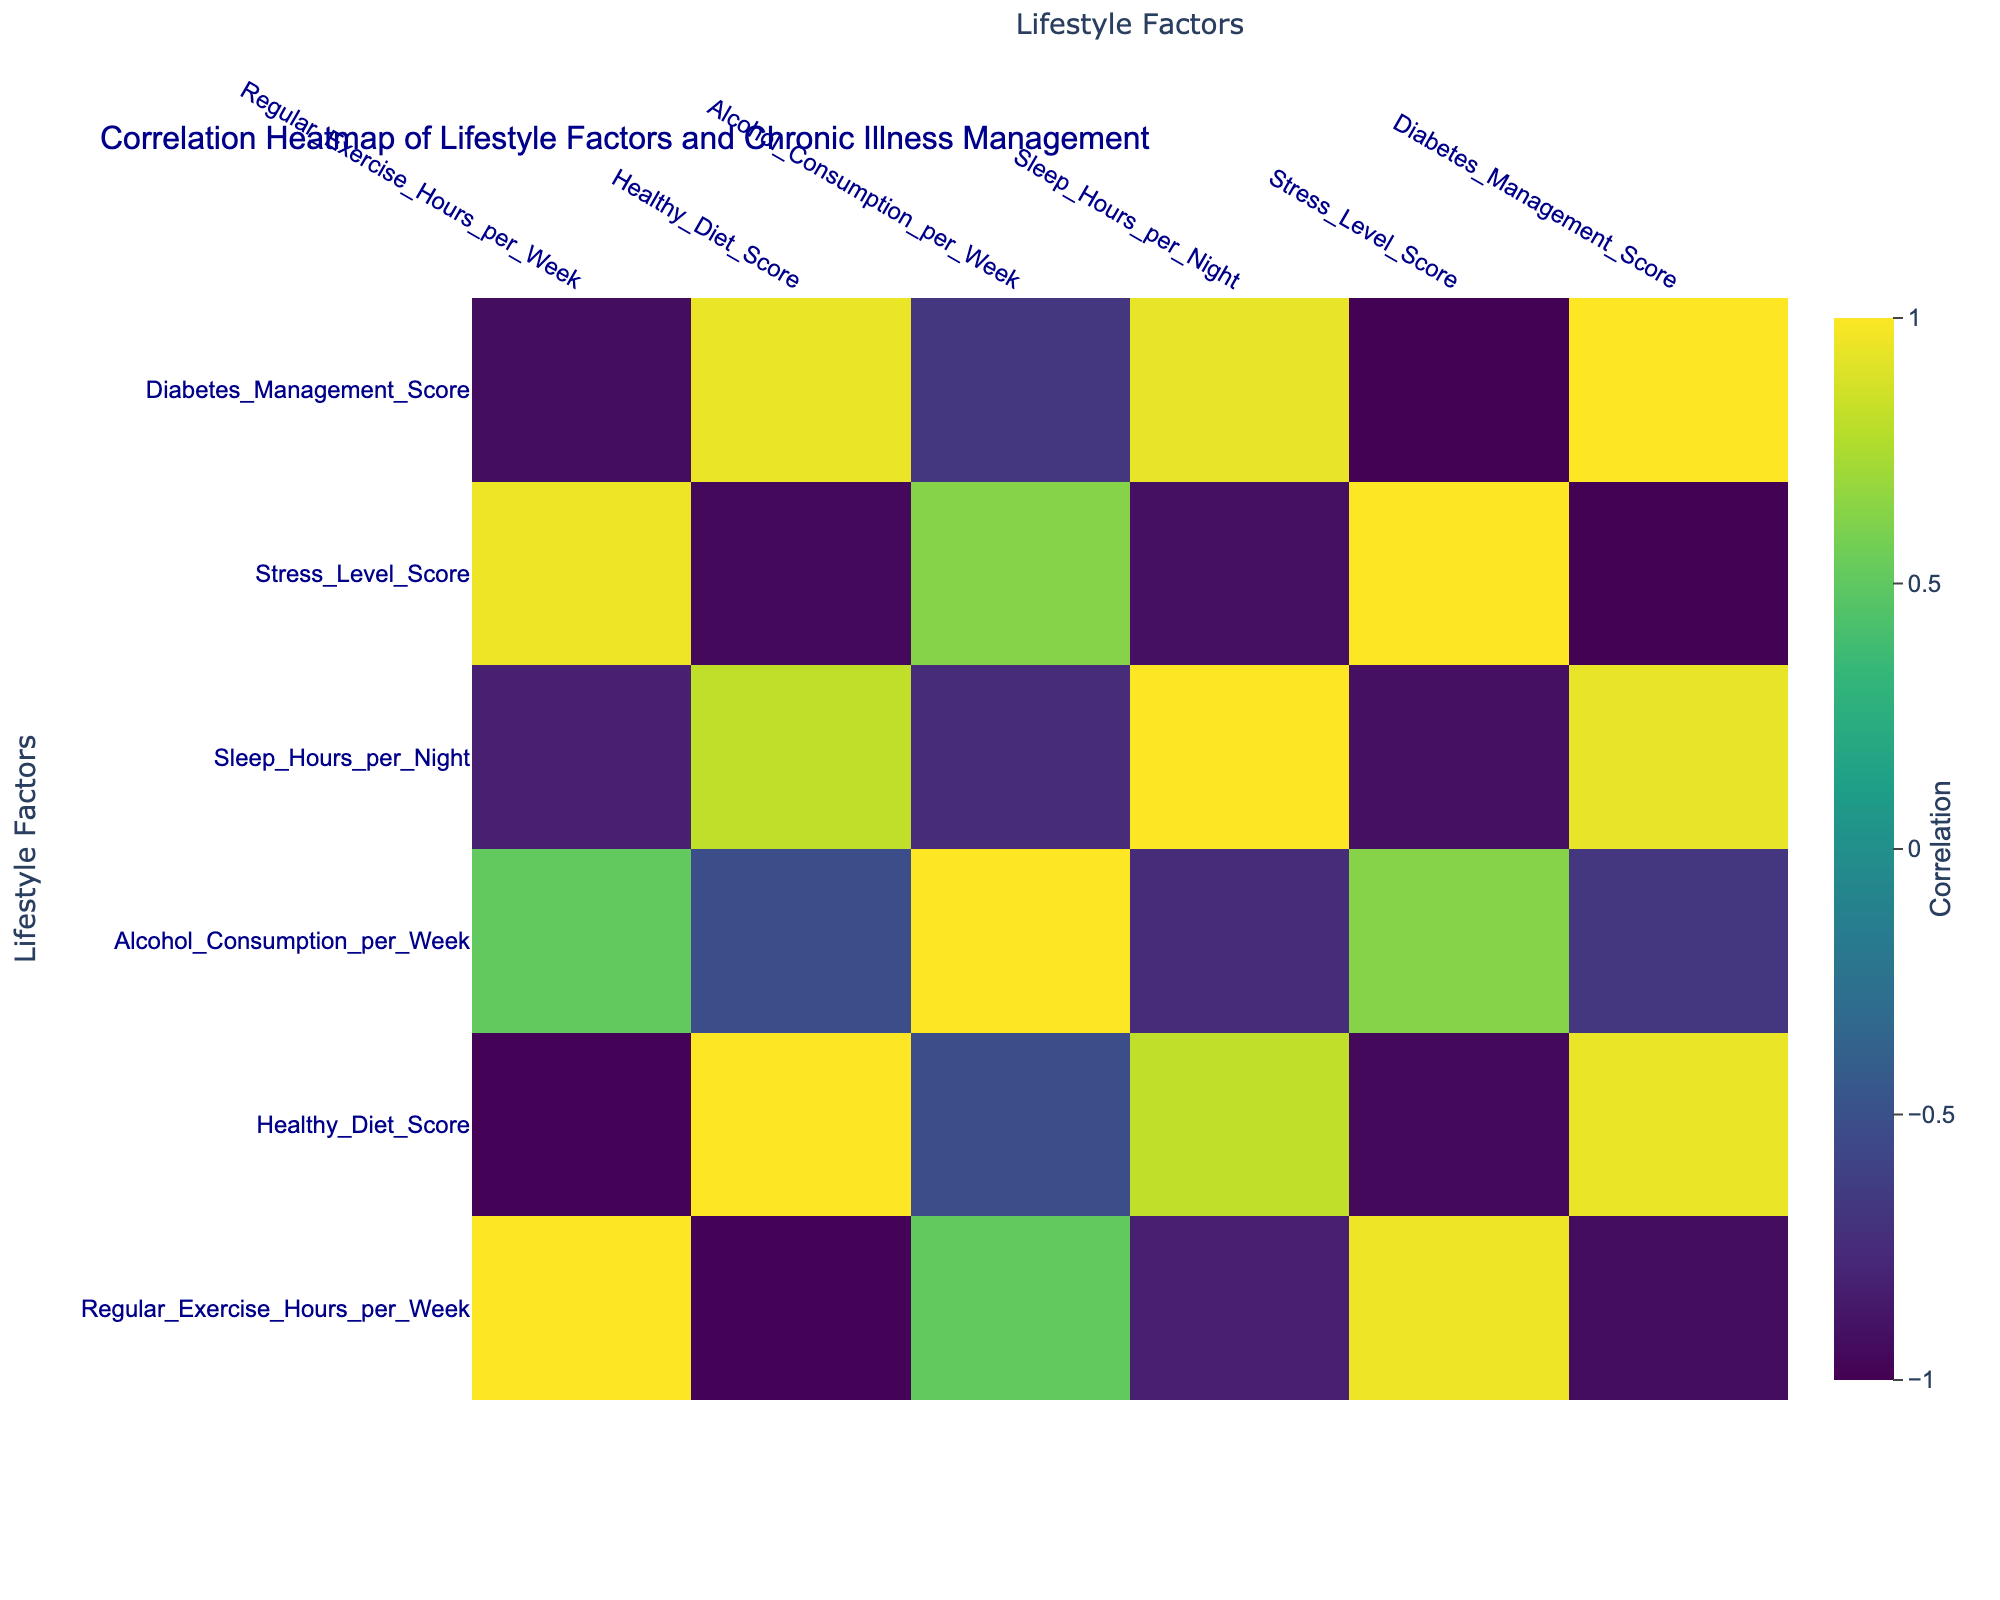What is the correlation between regular exercise hours per week and diabetes management score? The correlation coefficient value between regular exercise hours per week and diabetes management score can be found in the table. After checking the correlation matrix, we see that the value is positive, indicating that as exercise hours increase, the diabetes management score tends to improve.
Answer: Positive correlation Is smoking status correlated with diabetes management score? To determine this, we look for the correlation value between smoking status and diabetes management score in the table. Since smoking status is represented as categorical and not numeric, we cannot assign a correlation value. Hence, we could say that smoking status cannot be correlated with the diabetes management score in this dataset.
Answer: No What is the average healthy diet score for non-smokers in the dataset? First, identify the healthy diet scores for non-smokers by filtering the data. The scores for non-smokers are 8, 6, 5, 4, and 9. We sum these values (8 + 6 + 5 + 4 + 9 = 32) and divide by the number of non-smokers (5) to find the average, which is 32/5 = 6.4.
Answer: 6.4 How does stress level score vary with sleep hours per night? We will inspect the correlation value between stress level score and sleep hours per night in the table. By observing the correlation matrix, we will find a negative correlation value, suggesting that as sleep hours increase, the stress level score decreases, indicating improved management of stress.
Answer: Negative correlation Is there a direct relationship between alcohol consumption and diabetes management score? We refer to the correlation value between alcohol consumption per week and the diabetes management score in the table. The correlation value is negative, meaning that as alcohol consumption increases, diabetes management score appears to decrease, suggesting poor management of diabetes among those who consume more alcohol.
Answer: Yes, negative relationship What is the stress level score for the oldest age group in the dataset? The oldest age group is 70, and we find the corresponding stress level score in the table. Upon locating this entry, we see that the stress level score for the 70 age group is 7.
Answer: 7 How many lifestyle factors are positively correlated with diabetes management score? We will review all the correlation values between lifestyle factors and diabetes management score. If a factor has a correlation coefficient greater than 0, it indicates a positive correlation. By counting these factors in the correlation matrix, we find that four lifestyle factors are positively correlated with diabetes management score.
Answer: Four factors What is the average alcohol consumption for smokers in the dataset? First, we extract the alcohol consumption values for smokers, which are 5, 2, and 8. The sum of these values (5 + 2 + 8 = 15) will then be divided by the total number of smokers (3), yielding an average of 15/3 = 5.
Answer: 5 